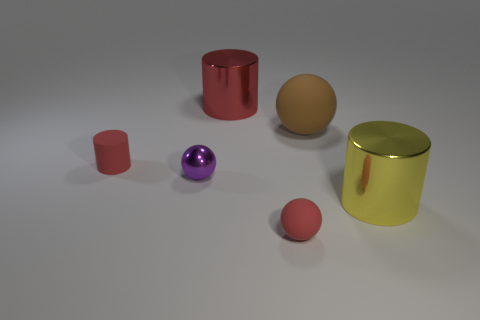Subtract all big red cylinders. How many cylinders are left? 2 Subtract all brown spheres. How many spheres are left? 2 Subtract all large brown cylinders. Subtract all metallic cylinders. How many objects are left? 4 Add 3 purple metallic balls. How many purple metallic balls are left? 4 Add 5 rubber objects. How many rubber objects exist? 8 Add 2 tiny red matte balls. How many objects exist? 8 Subtract 0 brown cylinders. How many objects are left? 6 Subtract all yellow cylinders. Subtract all red spheres. How many cylinders are left? 2 Subtract all yellow spheres. How many red cylinders are left? 2 